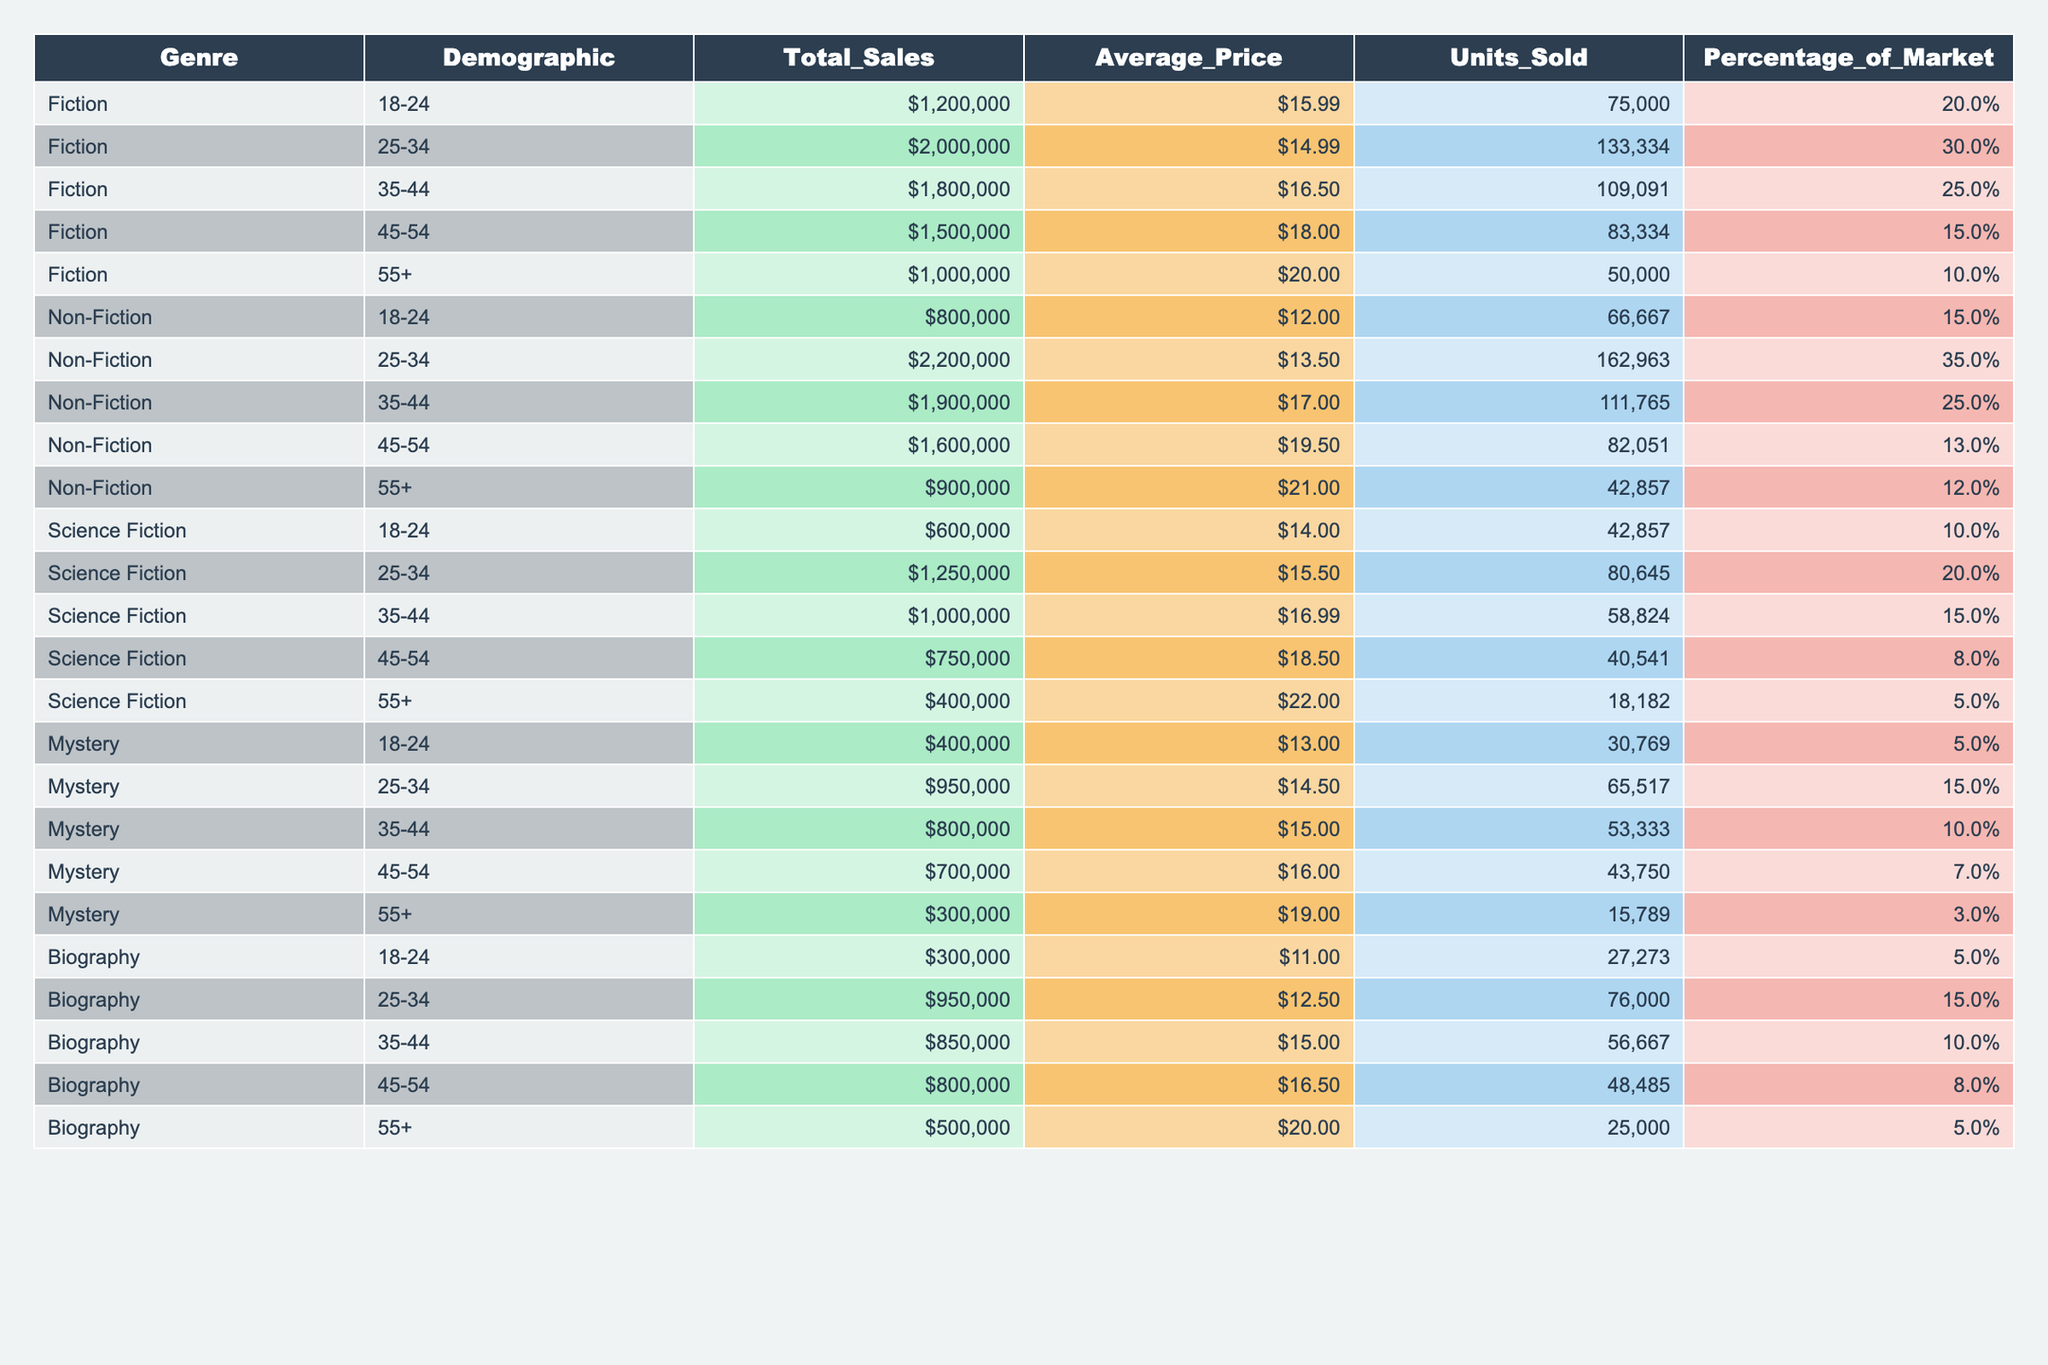What is the total sales for Fiction books? Referring to the table, the total sales for Fiction books is listed under the "Total_Sales" column for the Fiction genre. The value is $7,500,000 when we add the sales for each demographic: $1,200,000 + $2,000,000 + $1,800,000 + $1,500,000 + $1,000,000 = $7,500,000.
Answer: $7,500,000 What is the average price of Non-Fiction books sold to the 35-44 demographic? In the table, under the Non-Fiction genre, the average price for the 35-44 demographic is listed as $17.00.
Answer: $17.00 Which genre has the highest total sales figure for the 25-34 demographic? Looking at the 25-34 demographic in the table, Fiction shows total sales of $2,000,000, while Non-Fiction shows $2,200,000, Science Fiction shows $1,250,000, Mystery shows $950,000, and Biography shows $950,000. Therefore, Non-Fiction has the highest figure at $2,200,000.
Answer: Non-Fiction How many units of Science Fiction books were sold in the 45-54 demographic? The table indicates that for the Science Fiction genre, the number of units sold in the 45-54 demographic is 40,541.
Answer: 40,541 What is the percentage of the market for Biography books sold to the 55+ demographic compared to the percentage of the market for Science Fiction in the same demographic? For Biography, the percentage of the market for the 55+ demographic is 5.0%, while for Science Fiction in the same demographic, it is 5.0% as well. Since both values are the same, the difference is 0%.
Answer: 0% What is the total number of units sold for Fiction and Non-Fiction combined for the 45-54 demographic? Units sold for Fiction in the 45-54 demographic is 83,334 and for Non-Fiction it is 82,051. Adding these gives 83,334 + 82,051 = 165,385 units sold together.
Answer: 165,385 Does the 18-24 age group have higher total sales for Fiction or Mystery? From the table, Fiction sales for the 18-24 group is $1,200,000, while Mystery shows $400,000 for the same group. Since $1,200,000 is greater than $400,000, Fiction has higher sales.
Answer: Yes For which demographic does the Science Fiction genre have the lowest units sold? In the table, under Science Fiction, the units sold are listed for each demographic: 42,857 (18-24), 80,645 (25-34), 58,824 (35-44), 40,541 (45-54), and 18,182 (55+). The lowest number of units sold is 18,182 for the 55+ demographic.
Answer: 55+ demographic What is the average price of Mystery books across all demographics? The average price for Mystery books must be computed by summing the average prices across all demographics: ($13.00 + $14.50 + $15.00 + $16.00 + $19.00) and then dividing by the number of demographics: (13 + 14.5 + 15 + 16 + 19) / 5 = 15.1.
Answer: $15.10 How much total revenue was generated from Biography books sold to the 25-34 demographic? The total revenue from Biography sold to the 25-34 demographic can be calculated by multiplying the average price ($12.50) by the number of units sold (76,000): $12.50 * 76,000 = $950,000.
Answer: $950,000 Which genre has the lowest percentage of the market for the 55+ demographic? The table shows the percentages for 55+ demographics: Fiction is 10%, Non-Fiction is 12%, Science Fiction is 5%, Mystery is 3%, and Biography is 5%. Thus, Mystery has the lowest at 3%.
Answer: Mystery 